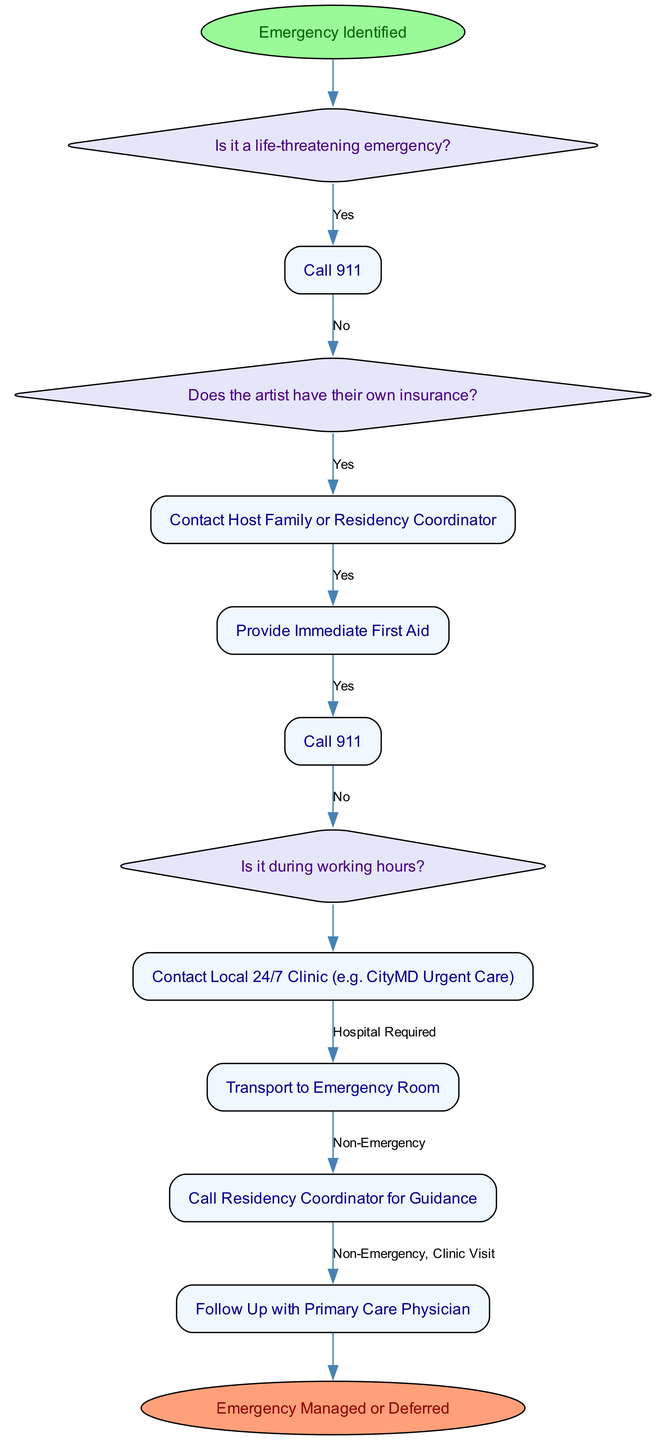What is the starting point of the pathway? The starting point, or the first node in the diagram, is labeled "Emergency Identified." This indicates the initial step when a medical situation arises.
Answer: Emergency Identified How many total actions are listed in the pathway? By counting the nodes of type "Action," we find there are multiple actions outlined in the diagram, totaling six distinct actions.
Answer: Six What decision follows the "Is it a life-threatening emergency?" node? The decision node that follows is "Does the artist have their own insurance?" This indicates the next step in determining how to proceed based on emergency conditions.
Answer: Does the artist have their own insurance? If the answer to "Is it a life-threatening emergency?" is yes, what is the first action taken? The first action taken in this case is "Call 911." This is directly related to responding to a life-threatening emergency, which requires immediate action.
Answer: Call 911 What happens if the artist does not have their own insurance? If the artist does not have their own insurance, the next step is to "Contact Host Family or Residency Coordinator" to address their insurance needs and support.
Answer: Contact Host Family or Residency Coordinator What is the final endpoint of the pathway? The final endpoint of the pathway is labeled "Emergency Managed or Deferred." This indicates the conclusion of the response process after addressing the emergency.
Answer: Emergency Managed or Deferred During which scenario should one contact a local 24/7 clinic? One should contact a local 24/7 clinic if the emergency is not during working hours, according to the flow of decisions in the diagram.
Answer: Not during working hours What action is taken if the incident is classified as non-emergency? If the situation is classified as a non-emergency, the action taken is to "Call Residency Coordinator for Guidance," which helps determine the next steps to take without urgent care.
Answer: Call Residency Coordinator for Guidance If hospitalization is required, what is the corresponding action? If hospitalization is determined to be required, the corresponding action is to "Transport to Emergency Room." This step ensures that the artist receives the medical attention needed.
Answer: Transport to Emergency Room 